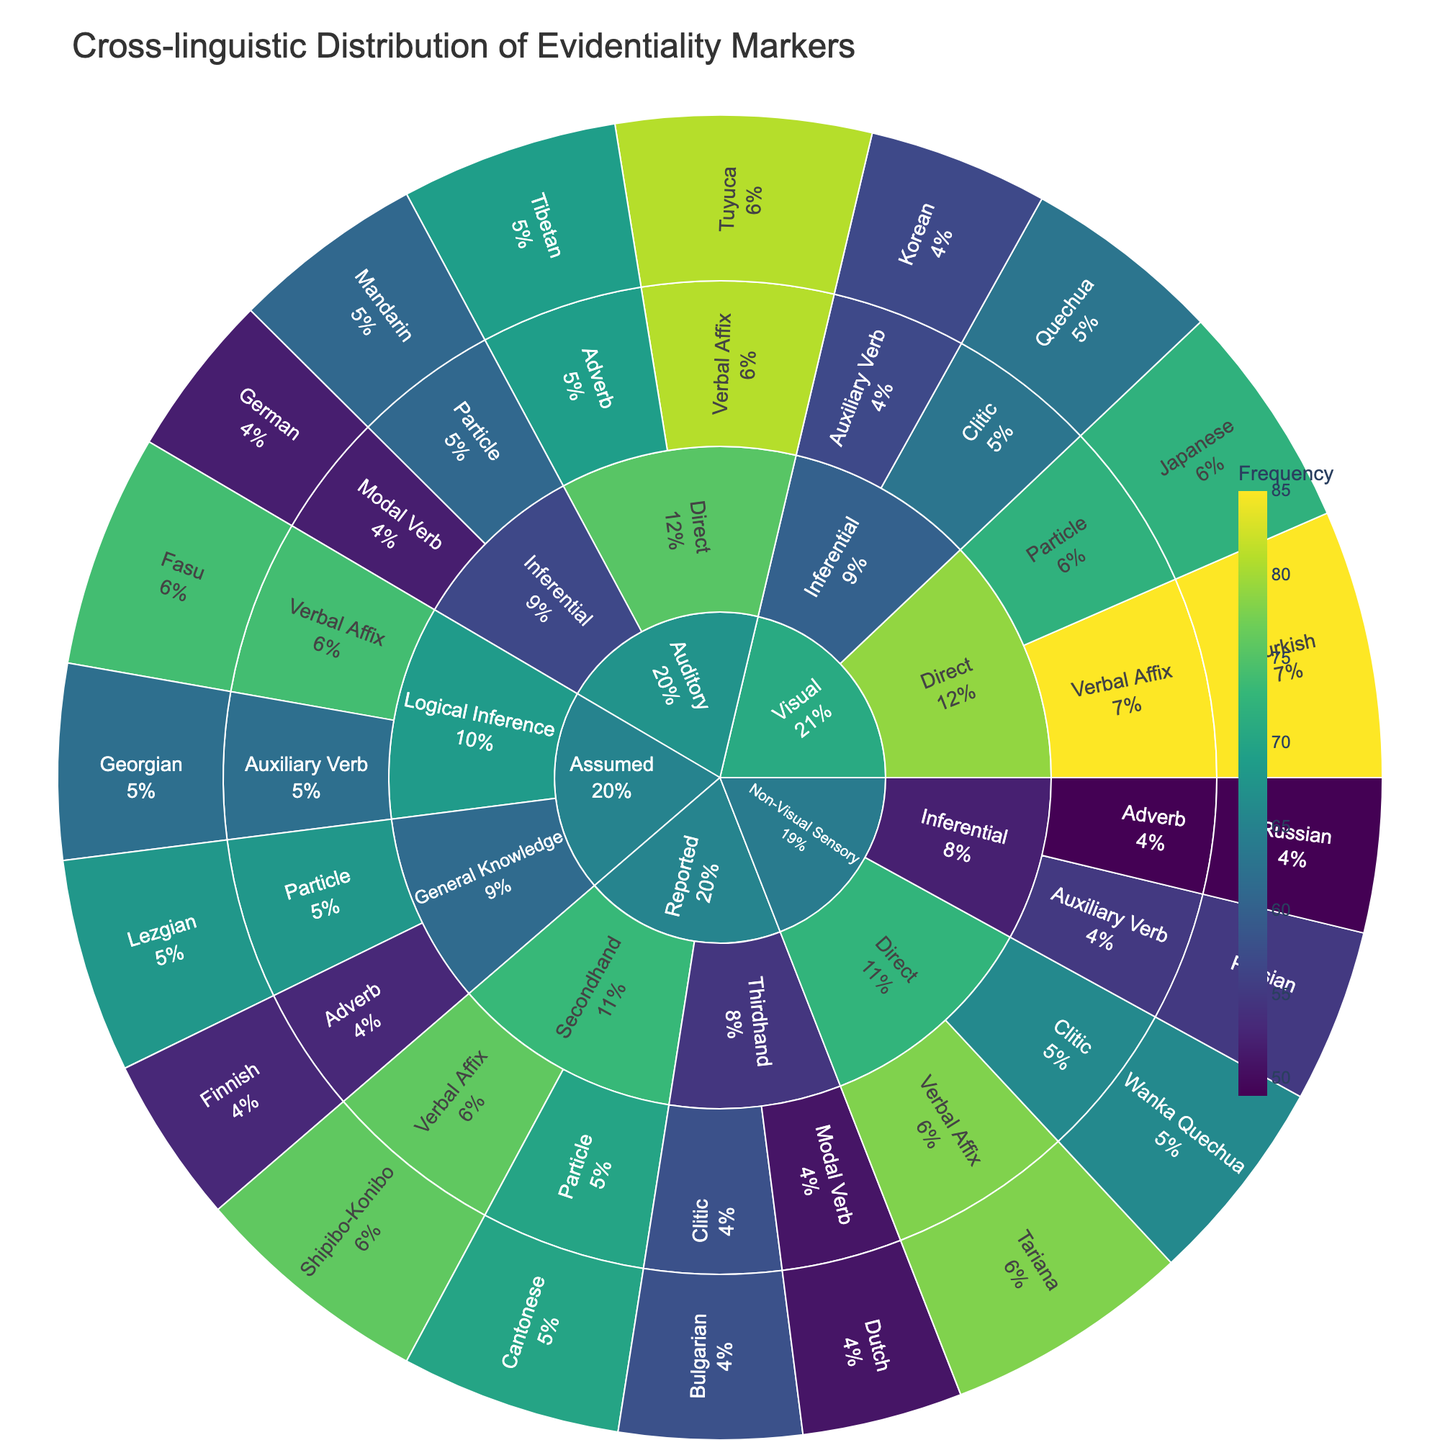What is the highest frequency of evidentiality markers in the 'Visual' category? To identify the highest frequency in the 'Visual' category, look at the segments under 'Visual'. The frequencies are Turkiah (85), Japanese (72), Quechua (63), and Korean (57). The highest value is with Turkish.
Answer: 85 What is the frequency of auditory direct verbal affixes? Locate the 'Auditory' category, then 'Direct', and then 'Verbal Affix'. The frequency for Tuyuca is shown as 81.
Answer: 81 How many languages use verbal affixes as evidentiality markers in the provided data? Identify all segments with 'Verbal Affix' under various categories: Turkish, Tuyuca, Tariana, Shipibo-Konibo, Fasu. There are 5 languages using verbal affixes.
Answer: 5 Which category has the highest total frequency of evidentiality markers? Sum up the frequencies for each category: Visual (277), Auditory (263), Non-Visual Sensory (248), Reported (255), Assumed (257). The 'Visual' category has the highest total frequency.
Answer: Visual What grammatical expression is most frequently used in the 'Reported' category? Under 'Reported' category, both 'Secondhand' (Verbal Affix - 76, Particle - 70) and 'Thirdhand' (Clitic - 58, Modal Verb - 51) sum up to: 'Verbal Affix' (76) is the most frequent.
Answer: Verbal Affix Which category and sub-category combination has the lowest frequency, and what is the value? Locate the segments with the lowest frequency across all sub-categories. The lowest frequency is 'Assumed' under 'General Knowledge', Adverb, Finnish which has a value of 53.
Answer: Assumed, General Knowledge, Adverb, Finnish, 53 Compare the frequency of inferential evidentiality markers in the 'Visual' and 'Auditory' categories. Which is higher? Sum the 'Inferential' frequencies for 'Visual': Quechua (63) + Korean (57) = 120. For 'Auditory': German (52) + Mandarin (61) = 113. The 'Visual' category is higher.
Answer: Visual What percentage of the total evidentiality markers are from the 'Assumed' category? Sum the frequencies for all categories: 277 (Visual) + 263 (Auditory) + 248 (Non-Visual Sensory) + 255 (Reported) + 257 (Assumed) = 1300. The 'Assumed' category frequency is 257. Calculate (257/1300) = 0.1977. So, around 19.8% of the total evidentiality markers are from 'Assumed'.
Answer: 19.8% Which sub-category in the 'Non-Visual Sensory' category has a higher total frequency, 'Direct' or 'Inferential'? Sum the frequencies under 'Non-Visual Sensory' for 'Direct' (Tariana - 78, Wanka Quechua - 66) = 144. For 'Inferential': Russian (49) + Persian (55) = 104. 'Direct' has a higher total frequency.
Answer: Direct 